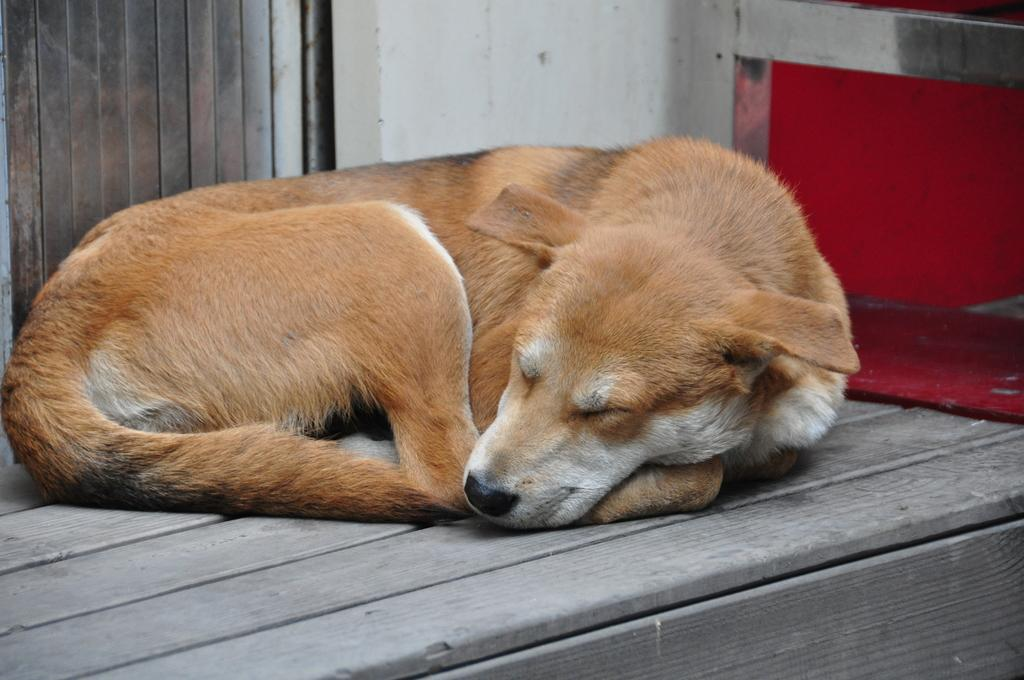What type of animal is in the image? There is a dog in the image. What color is the dog? The dog is black in color. What type of flooring is visible in the image? There is a wooden floor in the image. What can be seen in the background of the image? There is a wall in the background of the image. How many mice are hiding behind the wall in the image? There are no mice visible in the image, and it is not possible to determine if any are hiding behind the wall. 